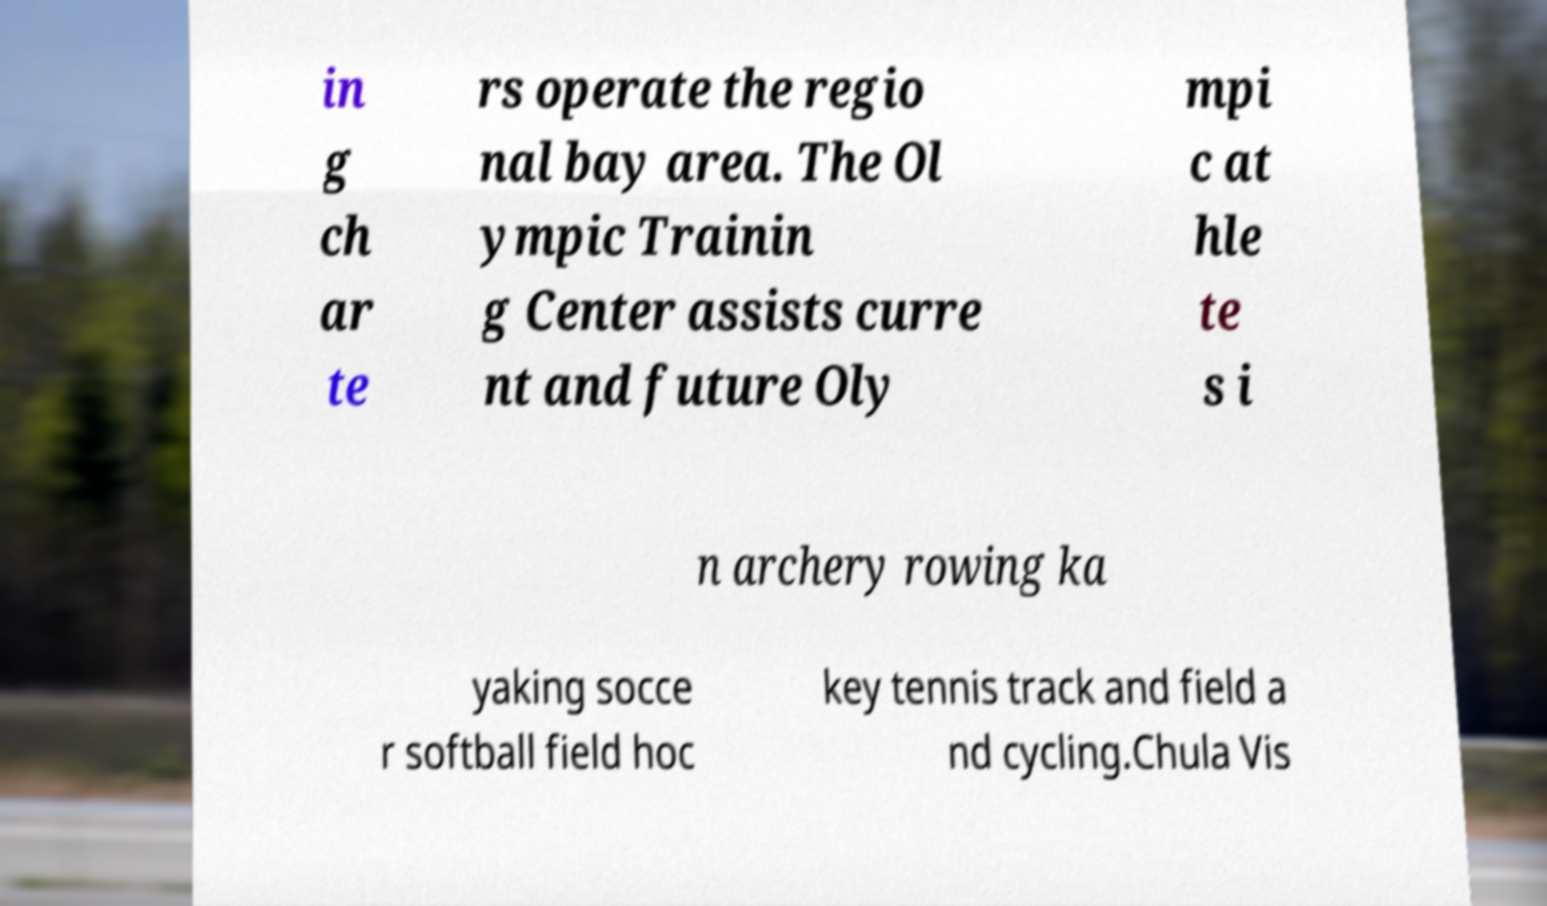Please identify and transcribe the text found in this image. in g ch ar te rs operate the regio nal bay area. The Ol ympic Trainin g Center assists curre nt and future Oly mpi c at hle te s i n archery rowing ka yaking socce r softball field hoc key tennis track and field a nd cycling.Chula Vis 